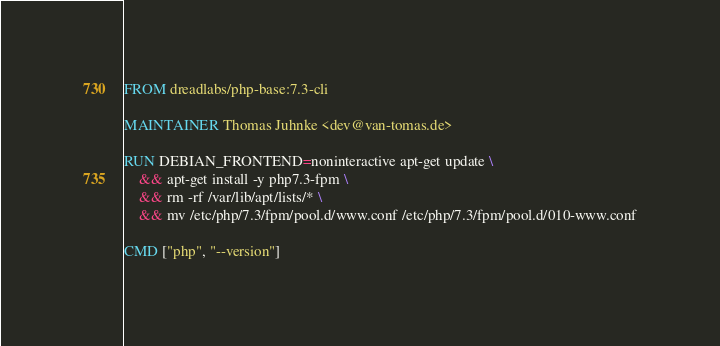<code> <loc_0><loc_0><loc_500><loc_500><_Dockerfile_>FROM dreadlabs/php-base:7.3-cli

MAINTAINER Thomas Juhnke <dev@van-tomas.de>

RUN DEBIAN_FRONTEND=noninteractive apt-get update \
    && apt-get install -y php7.3-fpm \
    && rm -rf /var/lib/apt/lists/* \
    && mv /etc/php/7.3/fpm/pool.d/www.conf /etc/php/7.3/fpm/pool.d/010-www.conf

CMD ["php", "--version"]
</code> 